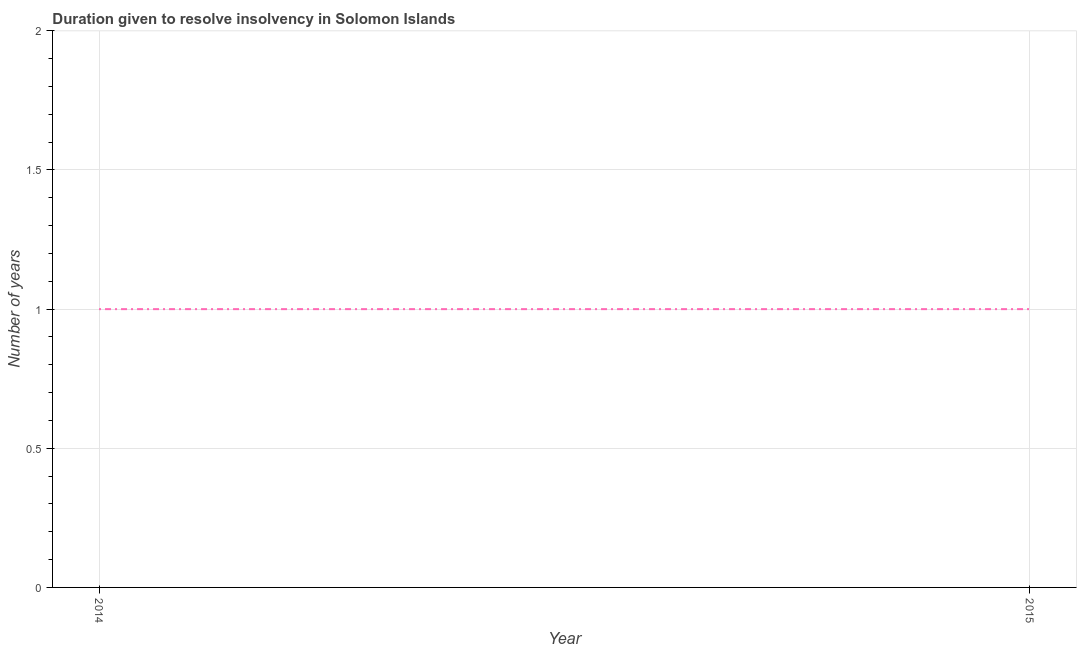What is the number of years to resolve insolvency in 2014?
Your response must be concise. 1. Across all years, what is the maximum number of years to resolve insolvency?
Make the answer very short. 1. Across all years, what is the minimum number of years to resolve insolvency?
Ensure brevity in your answer.  1. In which year was the number of years to resolve insolvency minimum?
Give a very brief answer. 2014. What is the sum of the number of years to resolve insolvency?
Offer a terse response. 2. What is the difference between the number of years to resolve insolvency in 2014 and 2015?
Your response must be concise. 0. What is the average number of years to resolve insolvency per year?
Give a very brief answer. 1. Do a majority of the years between 2015 and 2014 (inclusive) have number of years to resolve insolvency greater than 0.7 ?
Your answer should be very brief. No. Is the number of years to resolve insolvency in 2014 less than that in 2015?
Your answer should be very brief. No. In how many years, is the number of years to resolve insolvency greater than the average number of years to resolve insolvency taken over all years?
Keep it short and to the point. 0. Does the number of years to resolve insolvency monotonically increase over the years?
Your response must be concise. No. How many years are there in the graph?
Your answer should be very brief. 2. Does the graph contain any zero values?
Give a very brief answer. No. Does the graph contain grids?
Make the answer very short. Yes. What is the title of the graph?
Provide a short and direct response. Duration given to resolve insolvency in Solomon Islands. What is the label or title of the Y-axis?
Your response must be concise. Number of years. What is the Number of years in 2014?
Make the answer very short. 1. 